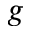Convert formula to latex. <formula><loc_0><loc_0><loc_500><loc_500>g</formula> 